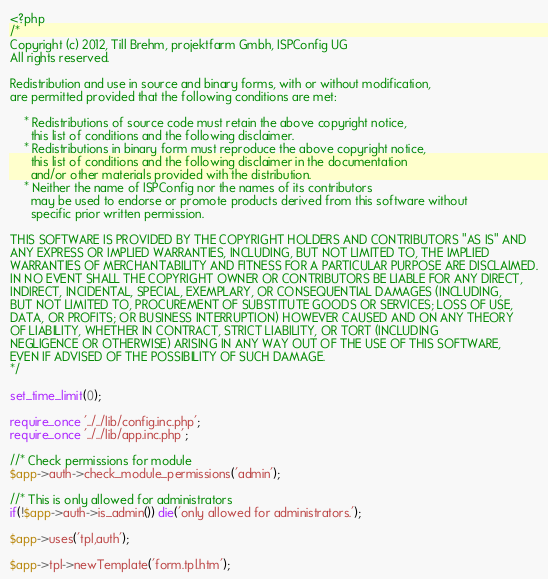<code> <loc_0><loc_0><loc_500><loc_500><_PHP_><?php
/*
Copyright (c) 2012, Till Brehm, projektfarm Gmbh, ISPConfig UG
All rights reserved.

Redistribution and use in source and binary forms, with or without modification,
are permitted provided that the following conditions are met:

    * Redistributions of source code must retain the above copyright notice,
      this list of conditions and the following disclaimer.
    * Redistributions in binary form must reproduce the above copyright notice,
      this list of conditions and the following disclaimer in the documentation
      and/or other materials provided with the distribution.
    * Neither the name of ISPConfig nor the names of its contributors
      may be used to endorse or promote products derived from this software without
      specific prior written permission.

THIS SOFTWARE IS PROVIDED BY THE COPYRIGHT HOLDERS AND CONTRIBUTORS "AS IS" AND
ANY EXPRESS OR IMPLIED WARRANTIES, INCLUDING, BUT NOT LIMITED TO, THE IMPLIED
WARRANTIES OF MERCHANTABILITY AND FITNESS FOR A PARTICULAR PURPOSE ARE DISCLAIMED.
IN NO EVENT SHALL THE COPYRIGHT OWNER OR CONTRIBUTORS BE LIABLE FOR ANY DIRECT,
INDIRECT, INCIDENTAL, SPECIAL, EXEMPLARY, OR CONSEQUENTIAL DAMAGES (INCLUDING,
BUT NOT LIMITED TO, PROCUREMENT OF SUBSTITUTE GOODS OR SERVICES; LOSS OF USE,
DATA, OR PROFITS; OR BUSINESS INTERRUPTION) HOWEVER CAUSED AND ON ANY THEORY
OF LIABILITY, WHETHER IN CONTRACT, STRICT LIABILITY, OR TORT (INCLUDING
NEGLIGENCE OR OTHERWISE) ARISING IN ANY WAY OUT OF THE USE OF THIS SOFTWARE,
EVEN IF ADVISED OF THE POSSIBILITY OF SUCH DAMAGE.
*/

set_time_limit(0);

require_once '../../lib/config.inc.php';
require_once '../../lib/app.inc.php';

//* Check permissions for module
$app->auth->check_module_permissions('admin');

//* This is only allowed for administrators
if(!$app->auth->is_admin()) die('only allowed for administrators.');

$app->uses('tpl,auth');

$app->tpl->newTemplate('form.tpl.htm');</code> 